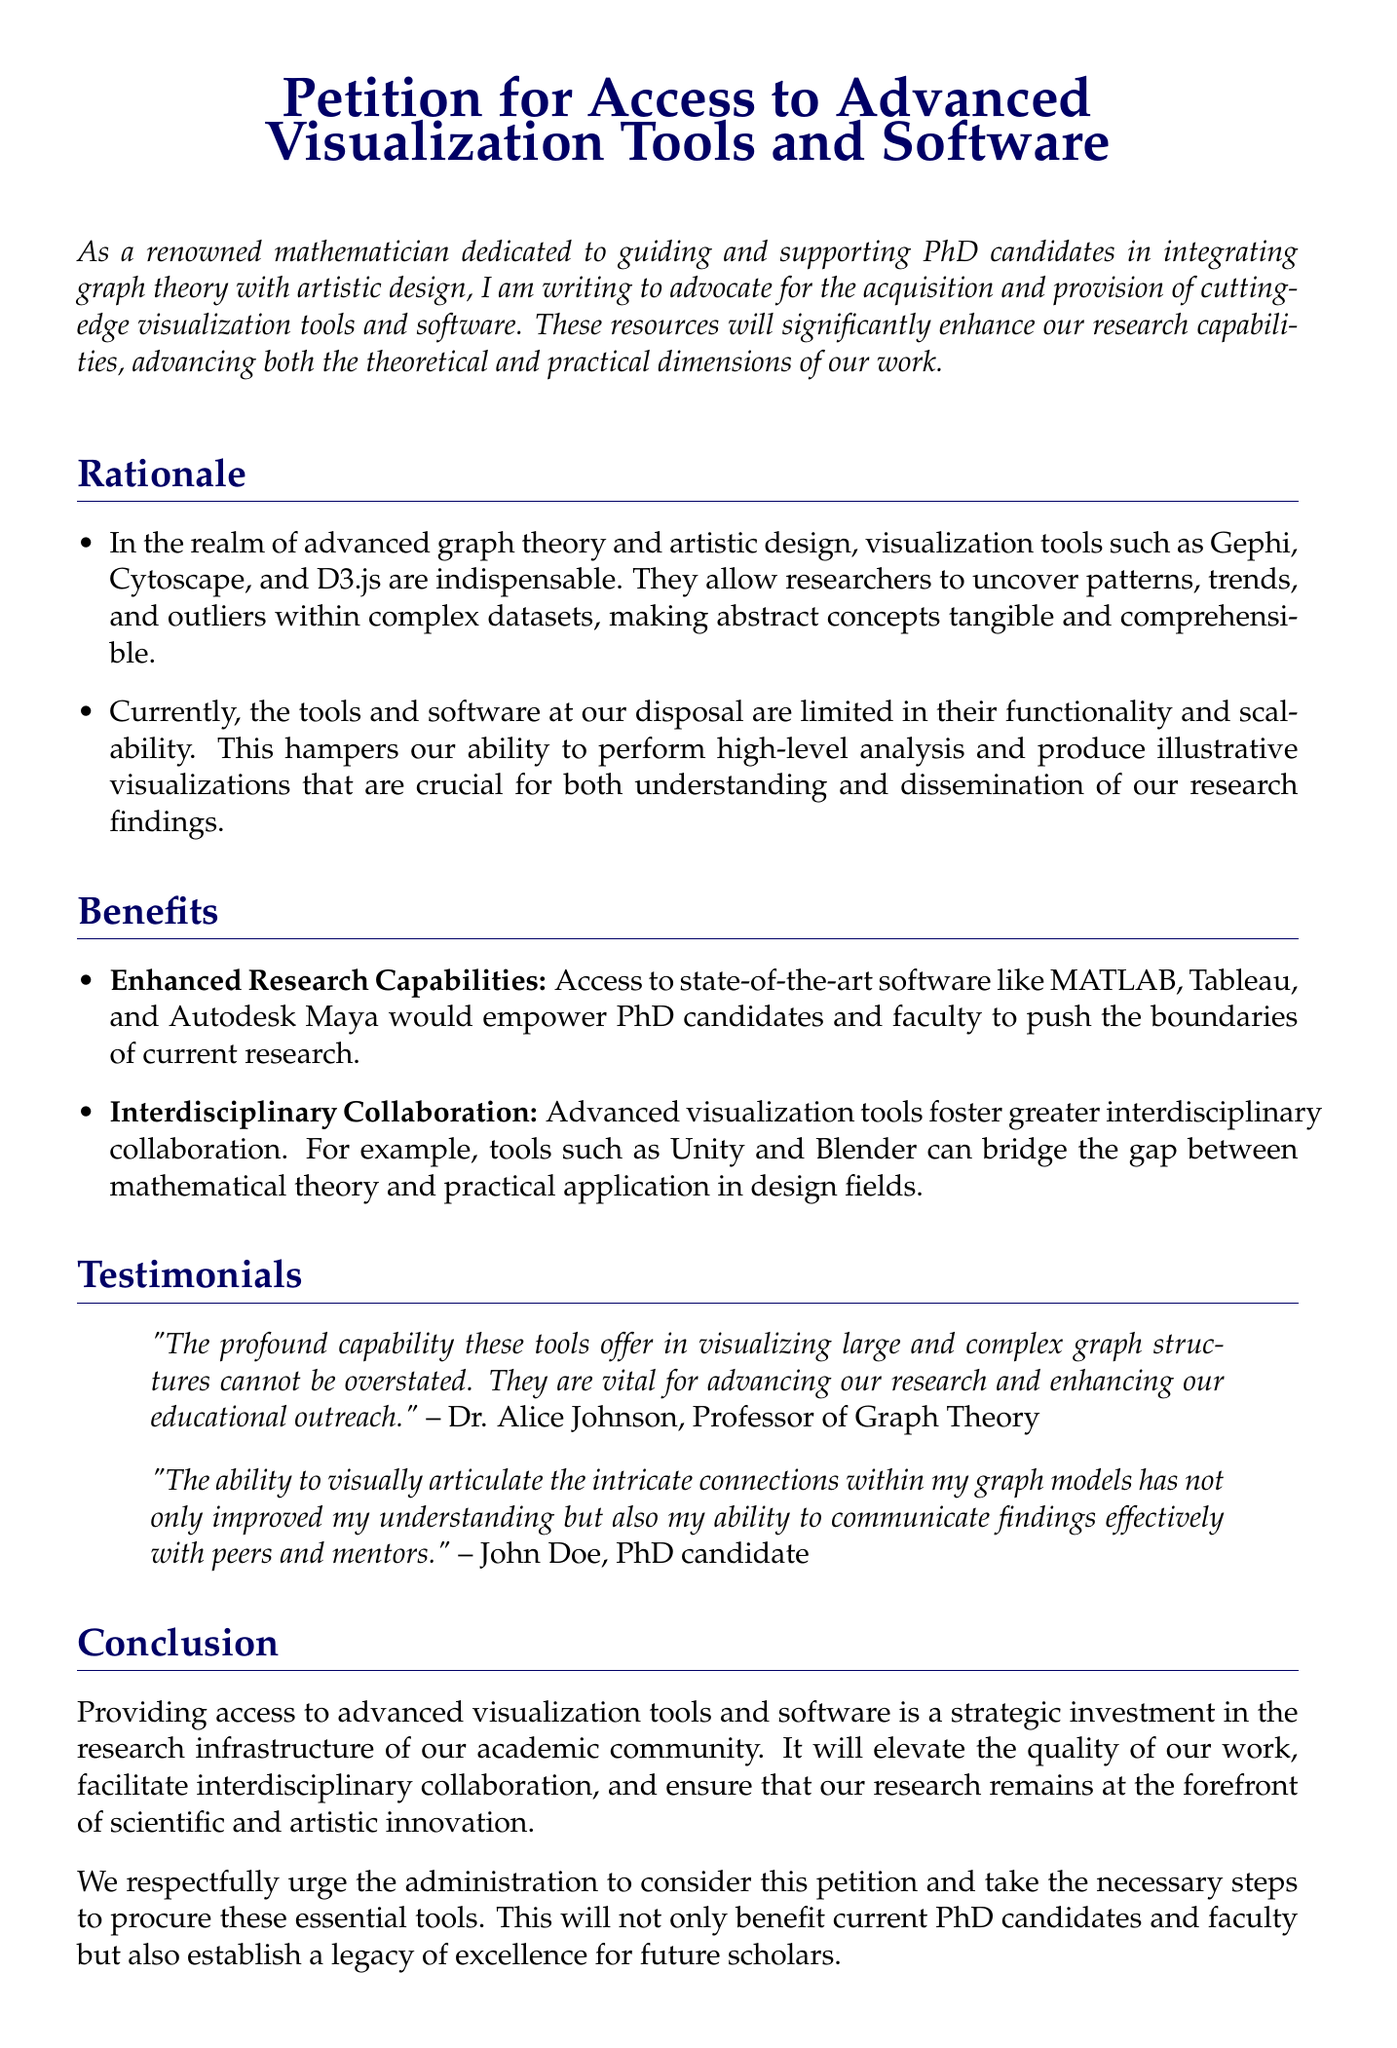What is the main purpose of the petition? The main purpose of the petition is to advocate for the acquisition and provision of cutting-edge visualization tools and software.
Answer: advocate for the acquisition of visualization tools Who is the author of the petition? The author of the petition is described as a renowned mathematician dedicated to guiding and supporting PhD candidates.
Answer: renowned mathematician Which visualization tools are mentioned in the rationale? The visualization tools mentioned include Gephi, Cytoscape, and D3.js.
Answer: Gephi, Cytoscape, D3.js What are two benefits listed for accessing state-of-the-art software? Two benefits listed are enhanced research capabilities and interdisciplinary collaboration.
Answer: enhanced research capabilities, interdisciplinary collaboration Who provided a testimonial in the document? The testimonial was provided by Dr. Alice Johnson, Professor of Graph Theory.
Answer: Dr. Alice Johnson Which software tools are recommended to empower PhD candidates and faculty? Recommended software tools include MATLAB, Tableau, and Autodesk Maya.
Answer: MATLAB, Tableau, Autodesk Maya What is the conclusion of the petition? The conclusion states that providing access to advanced visualization tools is a strategic investment in research infrastructure.
Answer: strategic investment in research infrastructure What is the tone of the petition? The tone of the petition is respectful and urging.
Answer: respectful and urging 